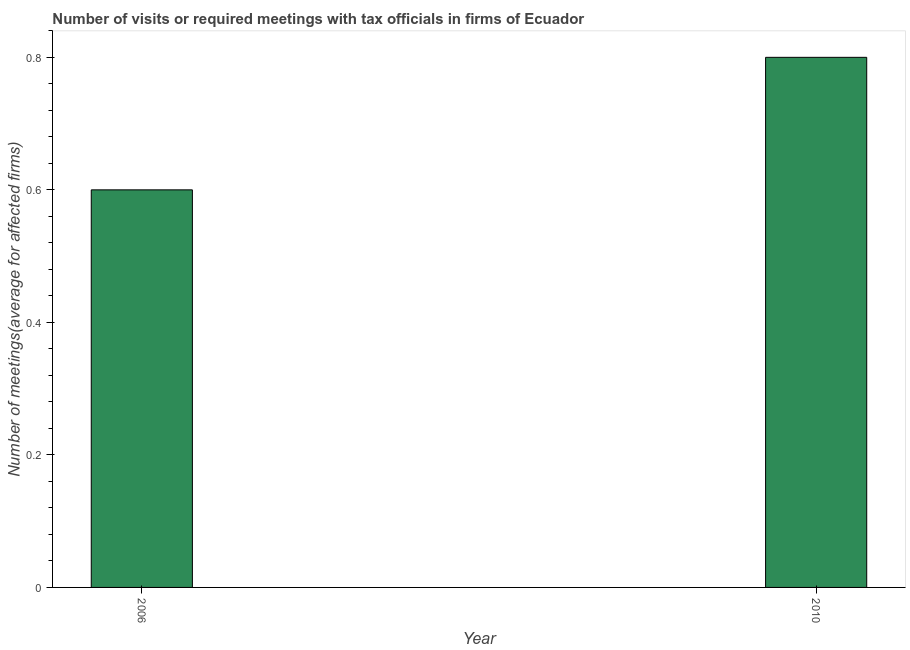What is the title of the graph?
Your answer should be very brief. Number of visits or required meetings with tax officials in firms of Ecuador. What is the label or title of the Y-axis?
Offer a very short reply. Number of meetings(average for affected firms). Across all years, what is the maximum number of required meetings with tax officials?
Your response must be concise. 0.8. In which year was the number of required meetings with tax officials maximum?
Provide a short and direct response. 2010. In which year was the number of required meetings with tax officials minimum?
Keep it short and to the point. 2006. What is the difference between the number of required meetings with tax officials in 2006 and 2010?
Keep it short and to the point. -0.2. What is the average number of required meetings with tax officials per year?
Your answer should be compact. 0.7. In how many years, is the number of required meetings with tax officials greater than 0.36 ?
Give a very brief answer. 2. Do a majority of the years between 2006 and 2010 (inclusive) have number of required meetings with tax officials greater than 0.04 ?
Give a very brief answer. Yes. Is the number of required meetings with tax officials in 2006 less than that in 2010?
Your answer should be very brief. Yes. Are all the bars in the graph horizontal?
Provide a succinct answer. No. What is the difference between two consecutive major ticks on the Y-axis?
Your answer should be very brief. 0.2. Are the values on the major ticks of Y-axis written in scientific E-notation?
Your answer should be compact. No. What is the Number of meetings(average for affected firms) in 2006?
Ensure brevity in your answer.  0.6. What is the difference between the Number of meetings(average for affected firms) in 2006 and 2010?
Your answer should be compact. -0.2. 